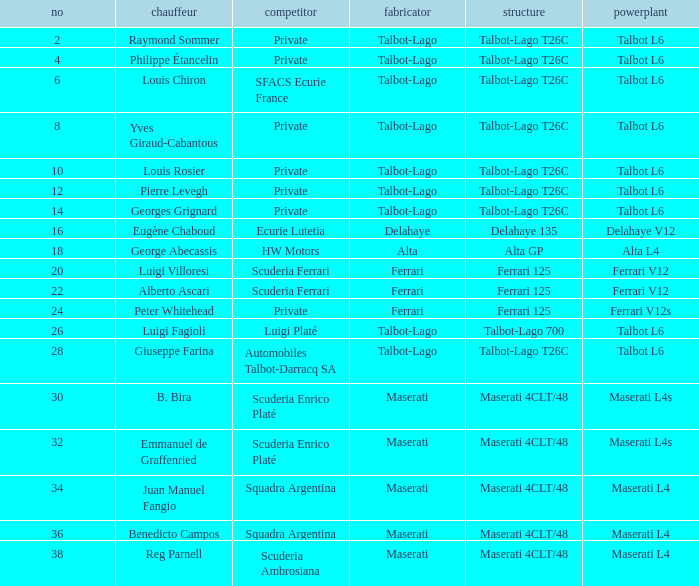Name the constructor for number 10 Talbot-Lago. 